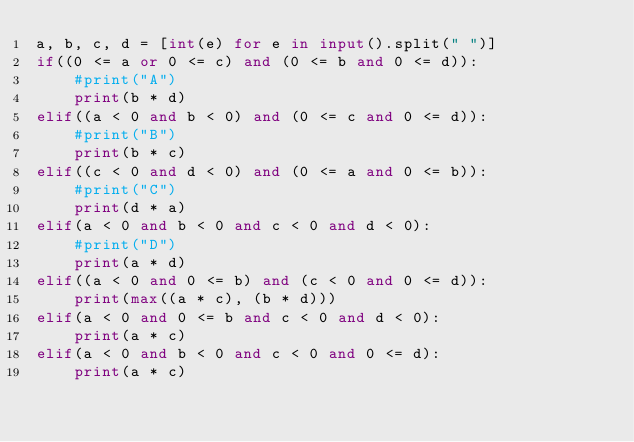Convert code to text. <code><loc_0><loc_0><loc_500><loc_500><_Python_>a, b, c, d = [int(e) for e in input().split(" ")]
if((0 <= a or 0 <= c) and (0 <= b and 0 <= d)):
    #print("A")
    print(b * d)
elif((a < 0 and b < 0) and (0 <= c and 0 <= d)):
    #print("B")
    print(b * c)
elif((c < 0 and d < 0) and (0 <= a and 0 <= b)):
    #print("C")
    print(d * a)
elif(a < 0 and b < 0 and c < 0 and d < 0):
    #print("D")
    print(a * d)
elif((a < 0 and 0 <= b) and (c < 0 and 0 <= d)):
    print(max((a * c), (b * d)))
elif(a < 0 and 0 <= b and c < 0 and d < 0):
    print(a * c)
elif(a < 0 and b < 0 and c < 0 and 0 <= d):
    print(a * c)</code> 